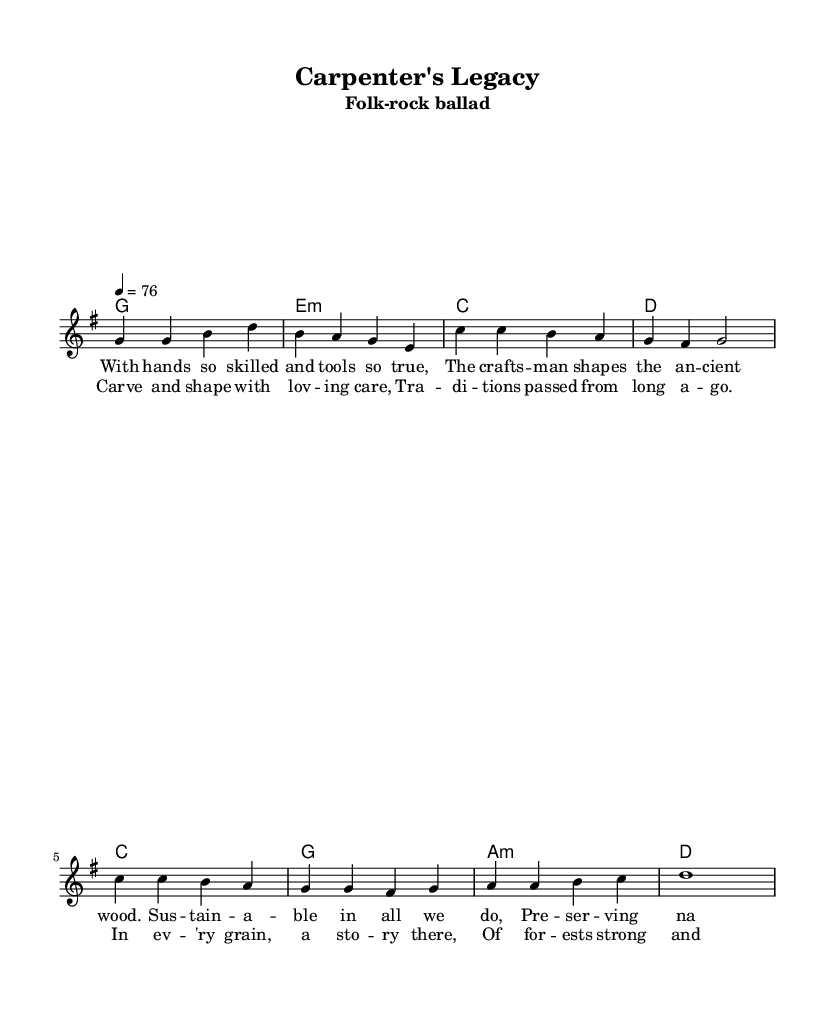What is the key signature of this music? The key signature is G major, which has one sharp (F#). This can be determined by the 'key g major' instruction in the global block of the LilyPond code.
Answer: G major What is the time signature of this music? The time signature is 4/4, which means there are four beats in each measure and a quarter note gets one beat. This can be found in the 'time 4/4' line within the global block of the code.
Answer: 4/4 What is the tempo of the piece? The tempo is set at 76 beats per minute, indicated by 'tempo 4 = 76' in the global block. This tells us how fast the music should be played.
Answer: 76 What instruments are indicated for this piece? The piece is arranged for vocals and accompanying chords. The presence of 'New Staff' and 'New Voice' indicates that there is a lead vocal part along with chord changes.
Answer: Vocals and chords How many verses are in the song? There is one verse present as indicated by the 'verseOne' label in the code, which contains lyrics for the first stanza. It distinguishes it from the chorus that follows.
Answer: One verse What themes are celebrated in the lyrics? The lyrics celebrate themes of craftsmanship, sustainability, and connection to nature, as indicated through phrases like "sustainable in all we do" and "preserving nature as we should." This reflects the message of the song.
Answer: Craftsmanship and sustainability How does the chorus relate to the verse musically? The chorus serves as a contrasting yet complementary section to the verse. It has a distinct melody and lyrics that reflect the same themes as the verse, creating a cohesive musical narrative throughout the song.
Answer: Complementary contrast 